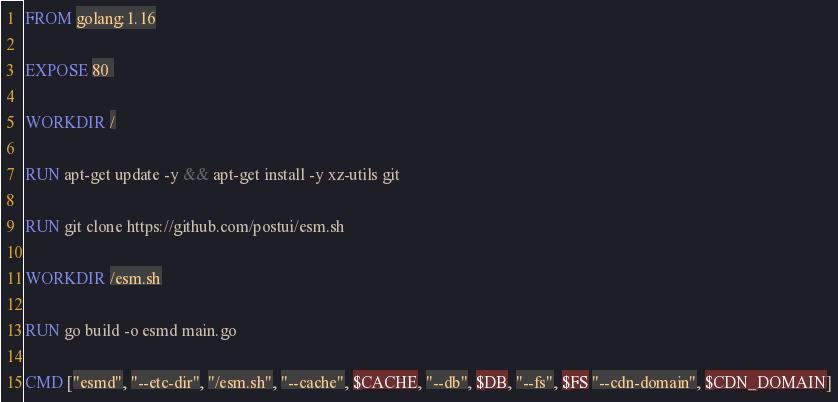Convert code to text. <code><loc_0><loc_0><loc_500><loc_500><_Dockerfile_>FROM golang:1.16

EXPOSE 80 

WORKDIR /

RUN apt-get update -y && apt-get install -y xz-utils git

RUN git clone https://github.com/postui/esm.sh

WORKDIR /esm.sh

RUN go build -o esmd main.go

CMD ["esmd", "--etc-dir", "/esm.sh", "--cache", $CACHE, "--db", $DB, "--fs", $FS "--cdn-domain", $CDN_DOMAIN]
</code> 